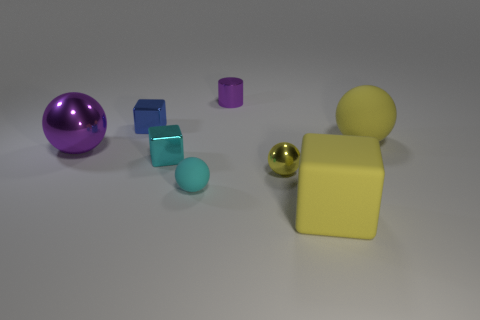Add 1 big balls. How many objects exist? 9 Subtract all big purple balls. Subtract all big purple metallic objects. How many objects are left? 6 Add 2 small blue metal things. How many small blue metal things are left? 3 Add 3 big green balls. How many big green balls exist? 3 Subtract all purple balls. How many balls are left? 3 Subtract all large rubber cubes. How many cubes are left? 2 Subtract 0 green cylinders. How many objects are left? 8 Subtract all blocks. How many objects are left? 5 Subtract 2 spheres. How many spheres are left? 2 Subtract all blue spheres. Subtract all yellow blocks. How many spheres are left? 4 